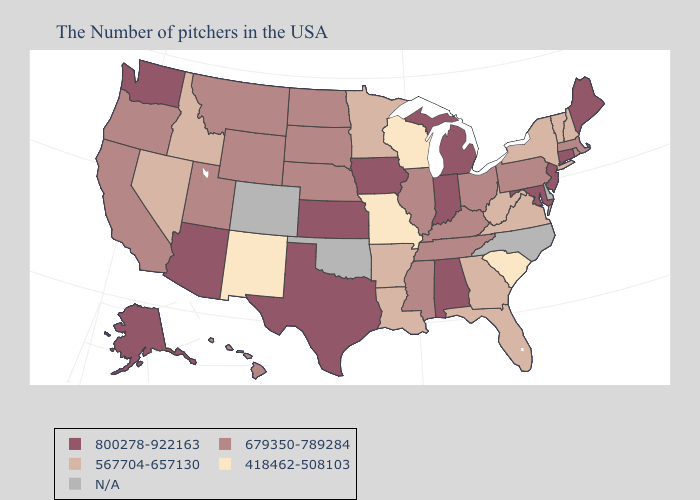Does the first symbol in the legend represent the smallest category?
Concise answer only. No. Does the first symbol in the legend represent the smallest category?
Keep it brief. No. Name the states that have a value in the range 679350-789284?
Keep it brief. Massachusetts, Rhode Island, Pennsylvania, Ohio, Kentucky, Tennessee, Illinois, Mississippi, Nebraska, South Dakota, North Dakota, Wyoming, Utah, Montana, California, Oregon, Hawaii. Name the states that have a value in the range 800278-922163?
Short answer required. Maine, Connecticut, New Jersey, Maryland, Michigan, Indiana, Alabama, Iowa, Kansas, Texas, Arizona, Washington, Alaska. What is the lowest value in states that border Vermont?
Keep it brief. 567704-657130. What is the value of Ohio?
Keep it brief. 679350-789284. What is the value of Connecticut?
Answer briefly. 800278-922163. Which states have the highest value in the USA?
Keep it brief. Maine, Connecticut, New Jersey, Maryland, Michigan, Indiana, Alabama, Iowa, Kansas, Texas, Arizona, Washington, Alaska. Among the states that border New Jersey , does New York have the highest value?
Write a very short answer. No. What is the highest value in the USA?
Keep it brief. 800278-922163. What is the value of Montana?
Short answer required. 679350-789284. Name the states that have a value in the range 418462-508103?
Keep it brief. South Carolina, Wisconsin, Missouri, New Mexico. What is the highest value in the USA?
Keep it brief. 800278-922163. What is the value of Maine?
Give a very brief answer. 800278-922163. Name the states that have a value in the range N/A?
Be succinct. Delaware, North Carolina, Oklahoma, Colorado. 